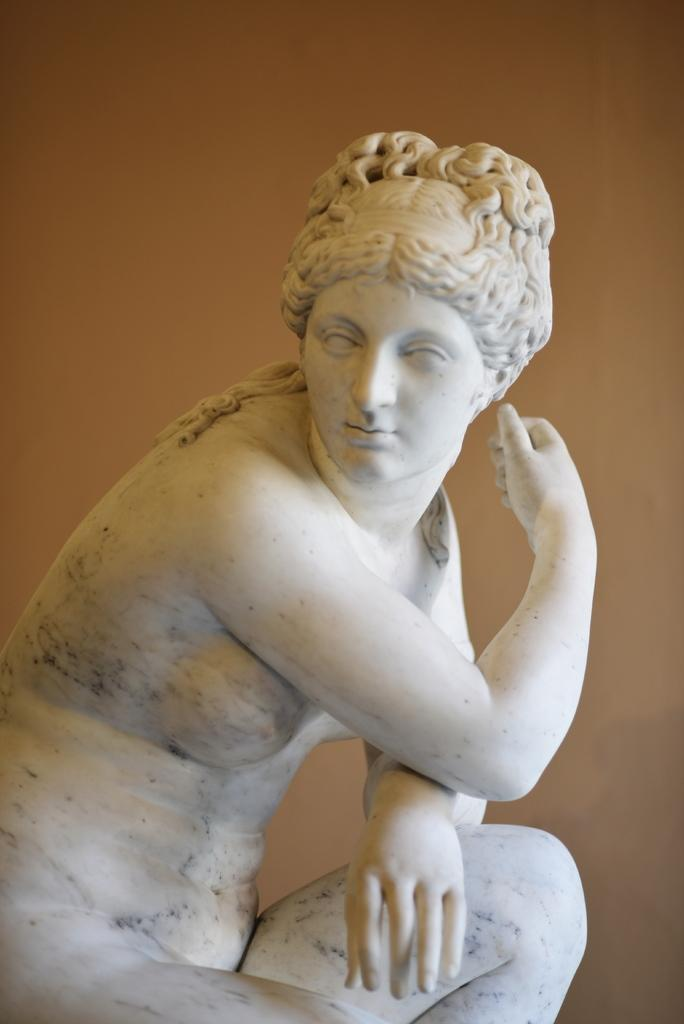What is the main subject of the image? There is a statue in the image. Can you describe the statue? The statue is of a woman. What color is the statue? The statue is white in color. Reasoning: Let' Let's think step by step in order to produce the conversation. We start by identifying the main subject of the image, which is the statue. Then, we describe the statue's subject matter, which is a woman. Finally, we mention the color of the statue, which is white. Each question is designed to elicit a specific detail about the image that is known from the provided facts. Absurd Question/Answer: What type of jam is the statue holding in the image? There is no jam present in the image; the statue is holding nothing. What type of soap is the woman in the statue using in the image? There is no soap or indication of any activity involving soap in the image. 